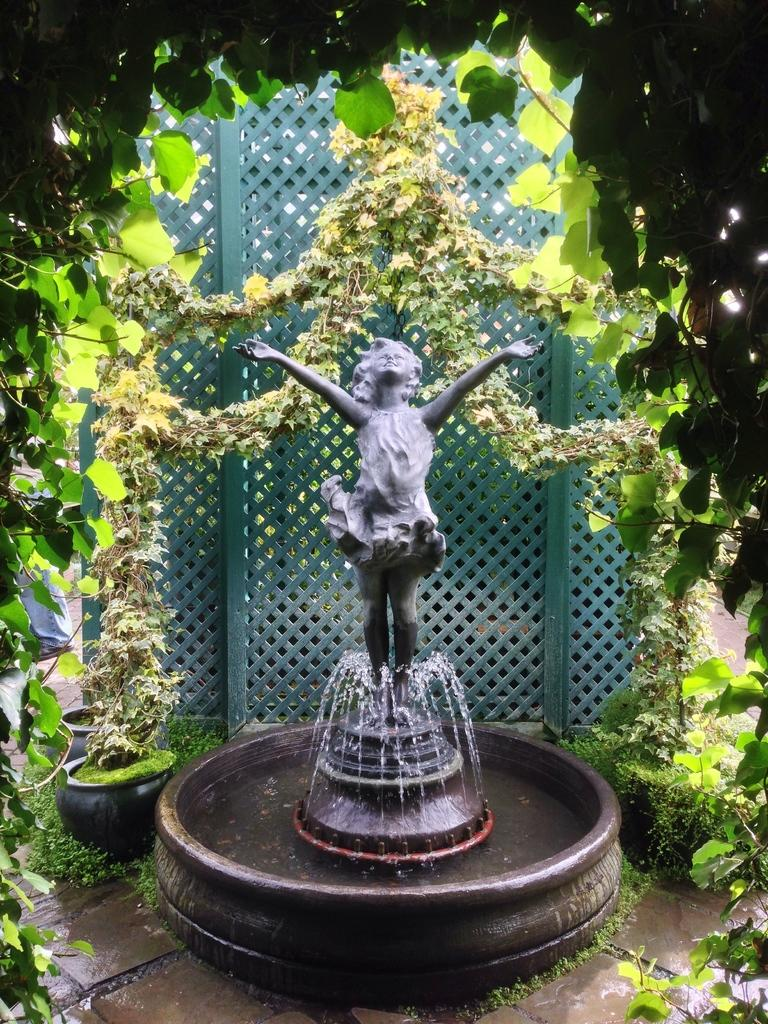What is the main subject in the image? There is a statue in the image. What other feature can be seen in the image? There is a fountain in the image. What type of vegetation is visible in the background? There are plants in the background of the image. What color are the plants? The plants are green in color. What other green element can be seen in the image? There is a green color railing in the image. What type of fruit is hanging from the statue in the image? There is no fruit present in the image; the statue and fountain are the main subjects. 